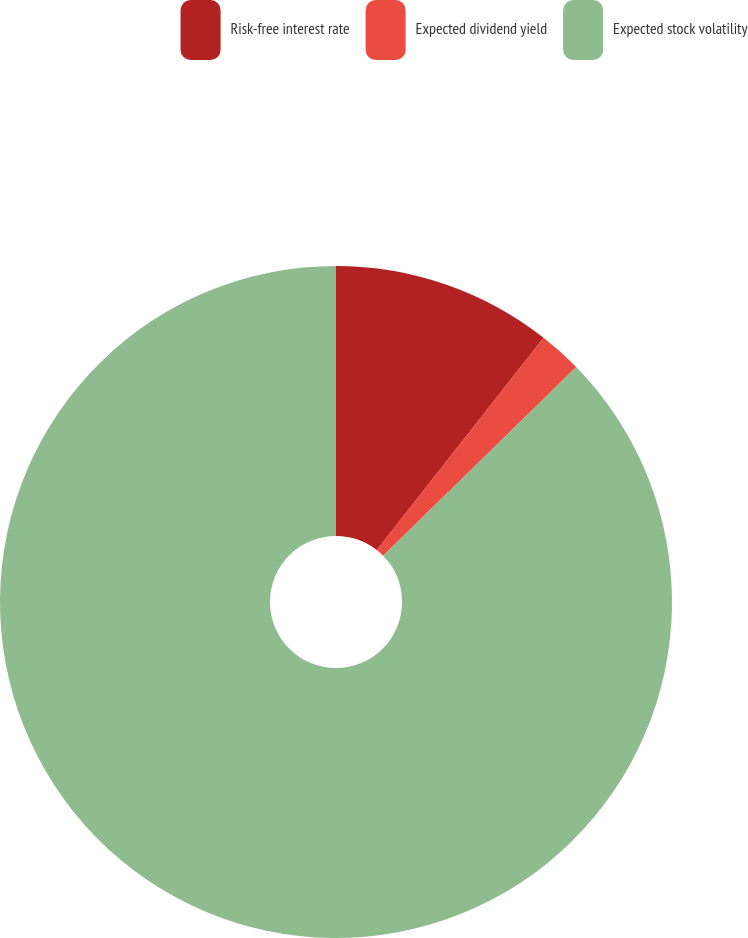Convert chart to OTSL. <chart><loc_0><loc_0><loc_500><loc_500><pie_chart><fcel>Risk-free interest rate<fcel>Expected dividend yield<fcel>Expected stock volatility<nl><fcel>10.6%<fcel>2.08%<fcel>87.32%<nl></chart> 